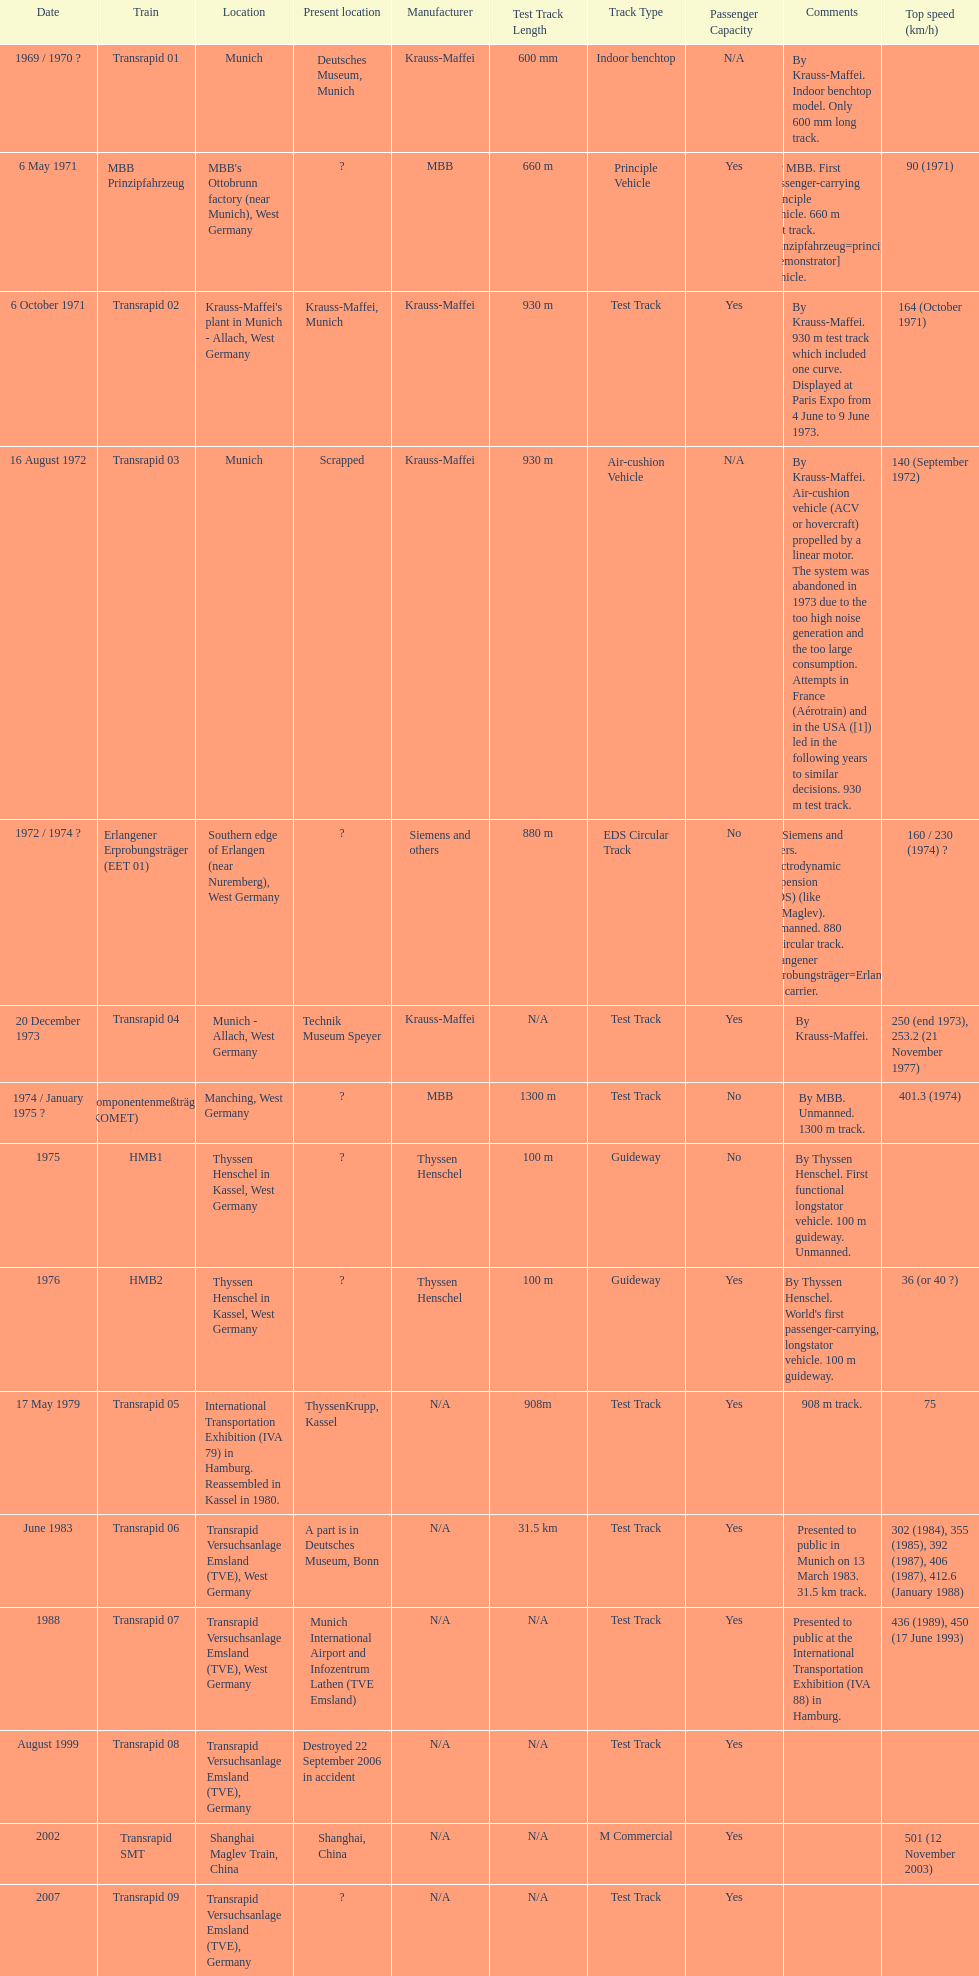Apart from the transrapid 07, how many trains are capable of exceeding 450km/h speeds? 1. 